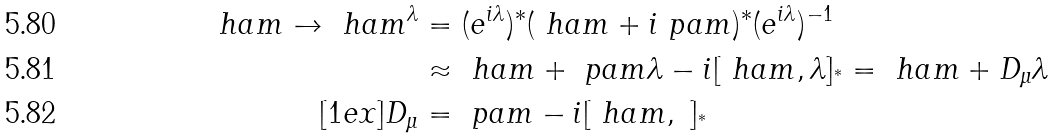Convert formula to latex. <formula><loc_0><loc_0><loc_500><loc_500>\ h a m \to \ h a m ^ { \lambda } & = ( e ^ { i \lambda } ) ^ { * } ( \ h a m + i \ p a m ) ^ { * } ( e ^ { i \lambda } ) ^ { - 1 } \\ & \approx \ h a m + \ p a m \lambda - i [ \ h a m , \lambda ] _ { ^ { * } } = \ h a m + D _ { \mu } \lambda \\ [ 1 e x ] D _ { \mu } & = \ p a m - i [ \ h a m , \ ] _ { ^ { * } }</formula> 